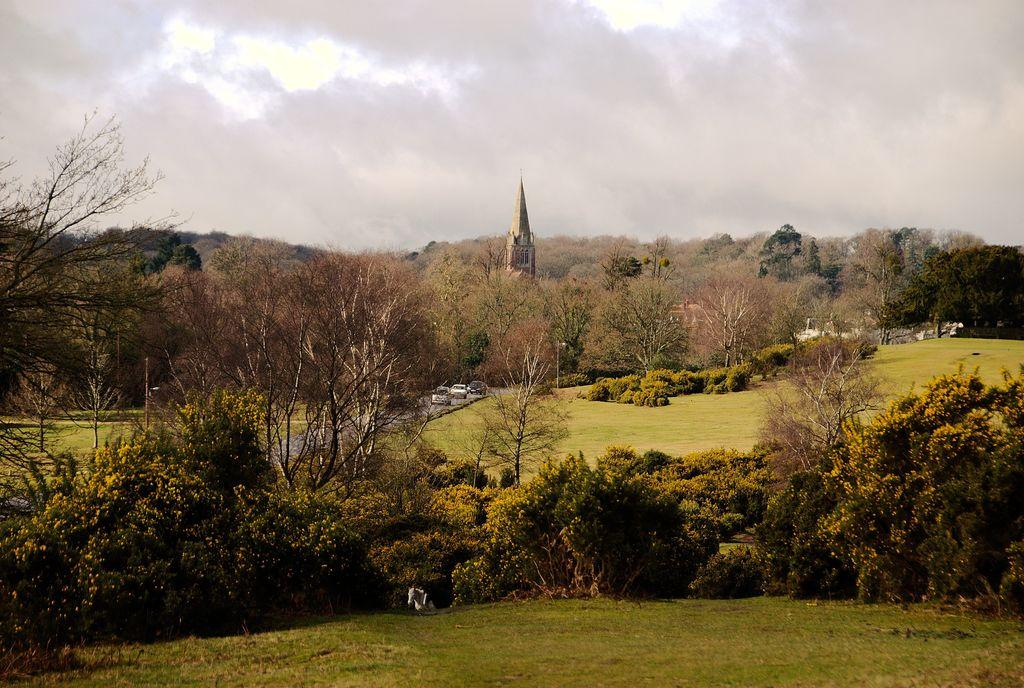What type of natural elements can be seen in the image? There are trees in the image. What type of man-made structures can be seen in the image? There are vehicles on the road, poles, and a tower in the image. What is visible at the bottom of the image? The ground is visible at the bottom of the image. What is visible at the top of the image? The sky is visible at the top of the image. What type of soap is being used to clean the society in the image? There is no soap or society present in the image. How does the ground interact with the society in the image? There is no society present in the image, and the ground is simply a visible surface at the bottom of the image. 